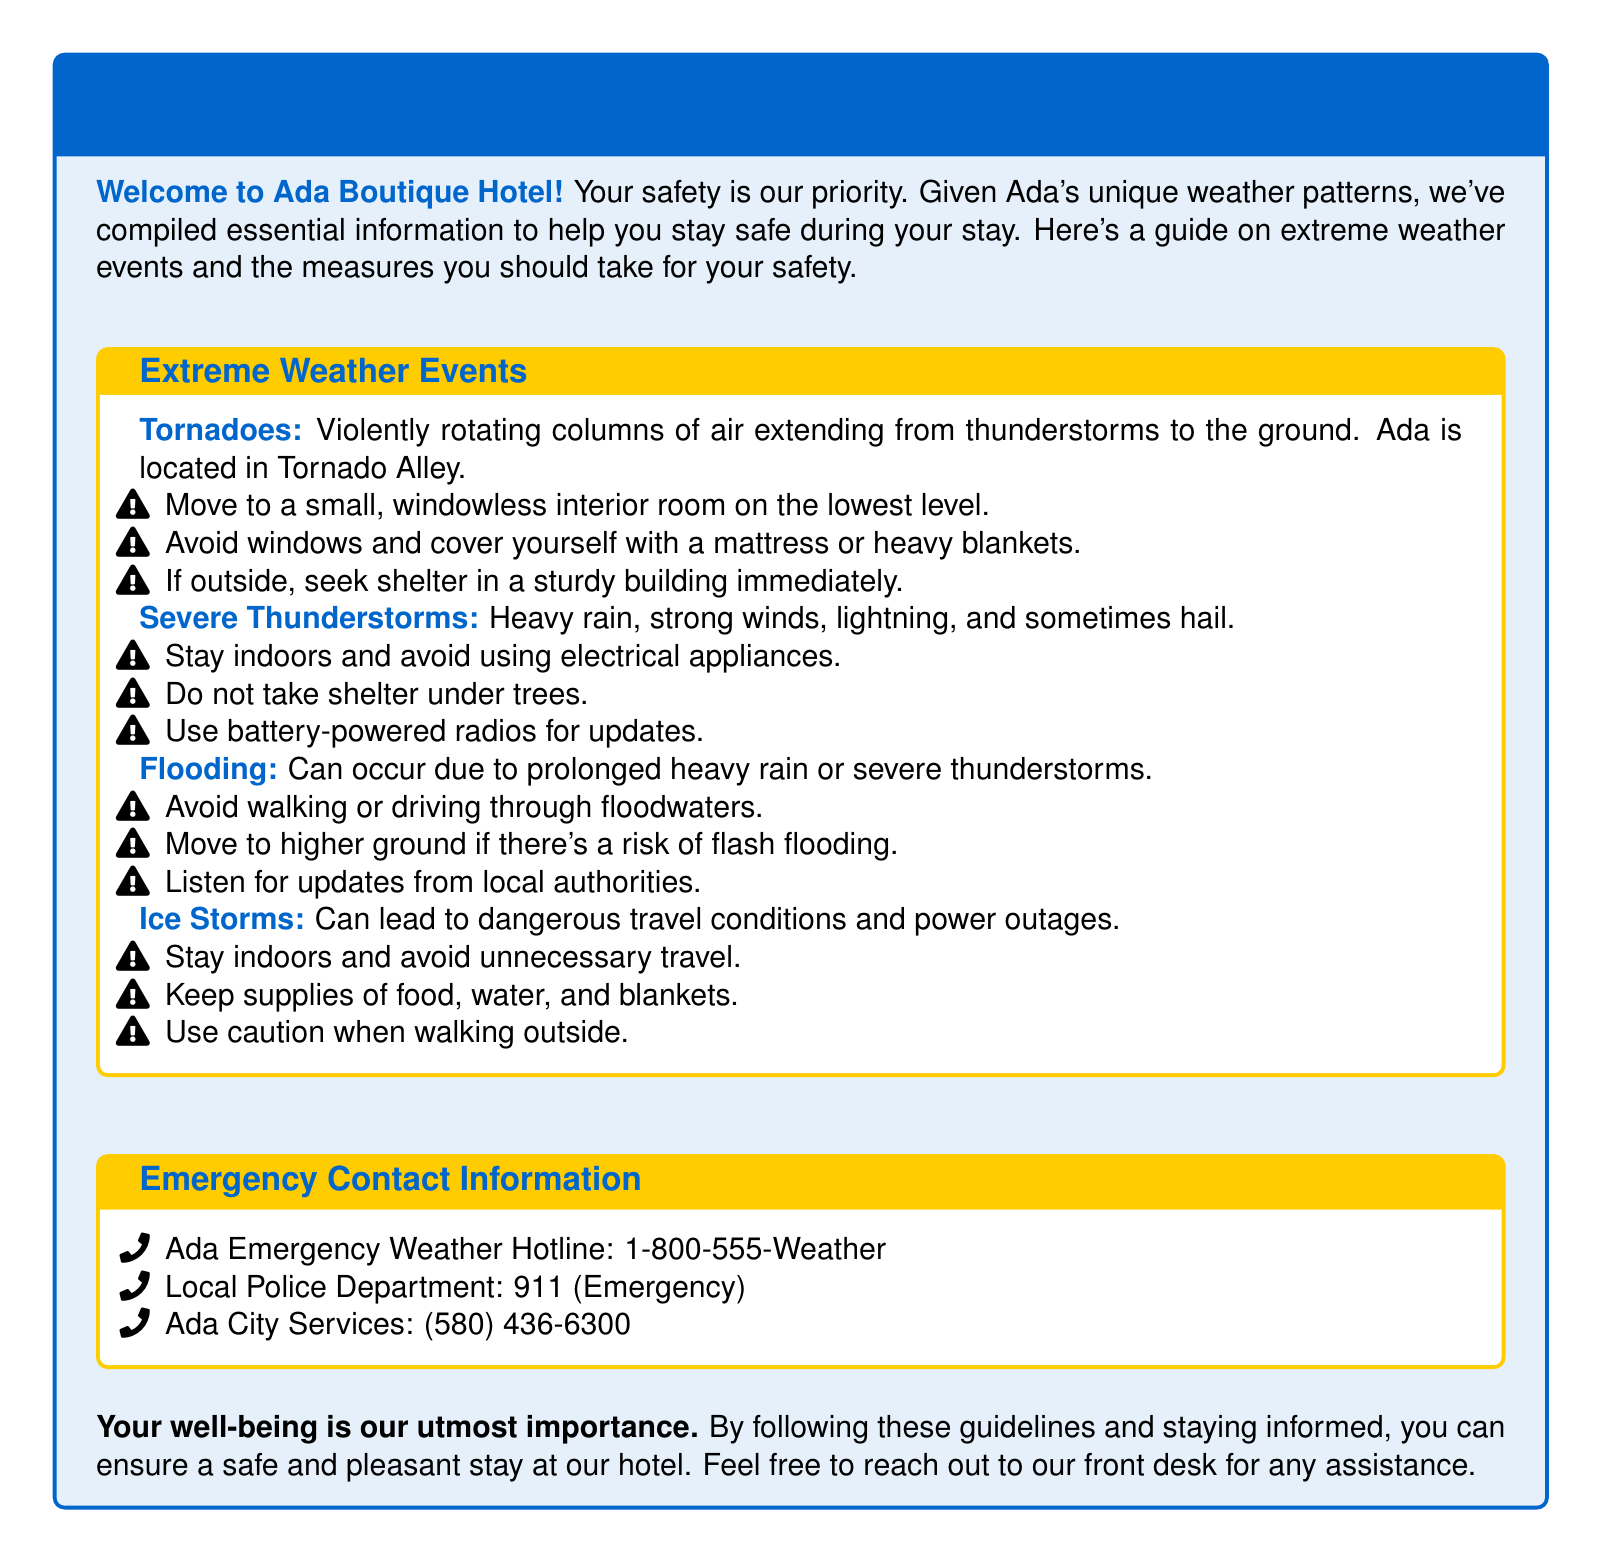What should you do during a tornado? The document lists actions to take during a tornado, including moving to a small, windowless room and avoiding windows.
Answer: Move to a small, windowless interior room on the lowest level What phone number should you call for the Ada Emergency Weather Hotline? The document provides contact information, including the Ada Emergency Weather Hotline's phone number.
Answer: 1-800-555-Weather What type of severe weather is Ada located in? The document mentions that Ada is located in Tornado Alley, indicating a specific type of severe weather.
Answer: Tornadoes What should you not do during a severe thunderstorm? The guidelines for severe thunderstorms include instructions on what not to do, specifically avoiding taking shelter under trees.
Answer: Do not take shelter under trees Where should you move if there's a risk of flash flooding? The document advises moving to higher ground if there's a risk of flash flooding.
Answer: Higher ground 